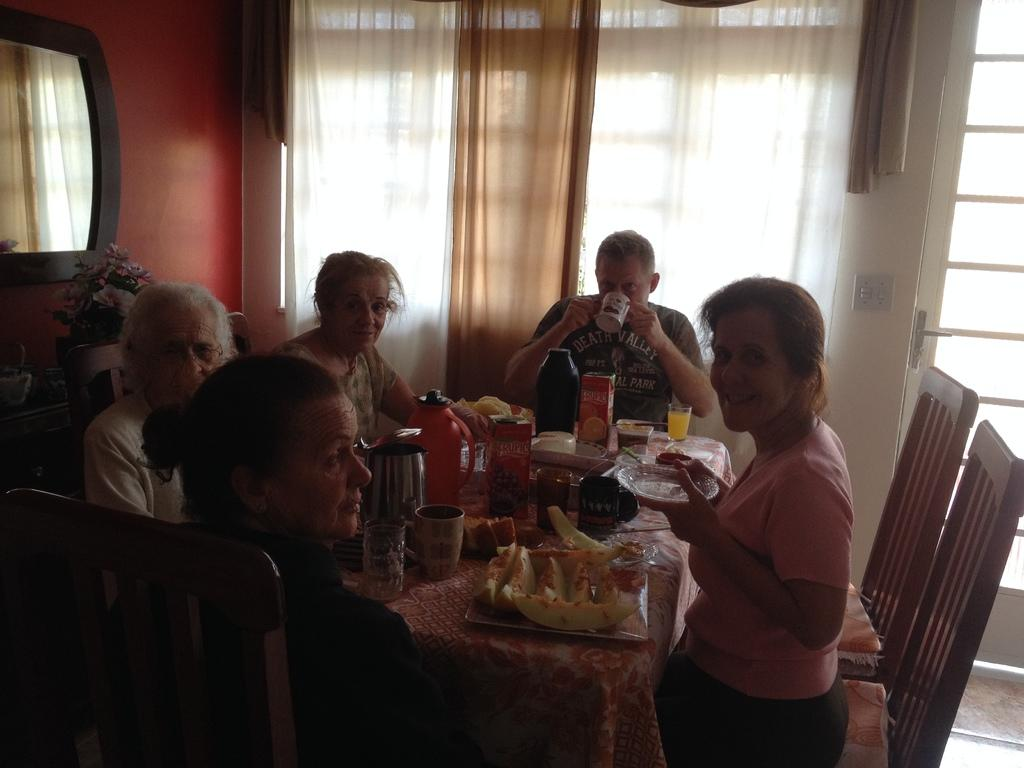What are the people in the image doing? The people in the image are sitting around the table. What objects can be seen on the table? There are glasses, a kettle, and food on the table. What type of window treatment is visible in the image? There are curtains visible in the image. What is hanging on the wall at the left side of the image? There is a mirror on the wall at the left side of the image. What type of coast can be seen in the image? There is no coast visible in the image; it features people sitting around a table with various objects. What color is the gold in the image? There is no gold present in the image. 